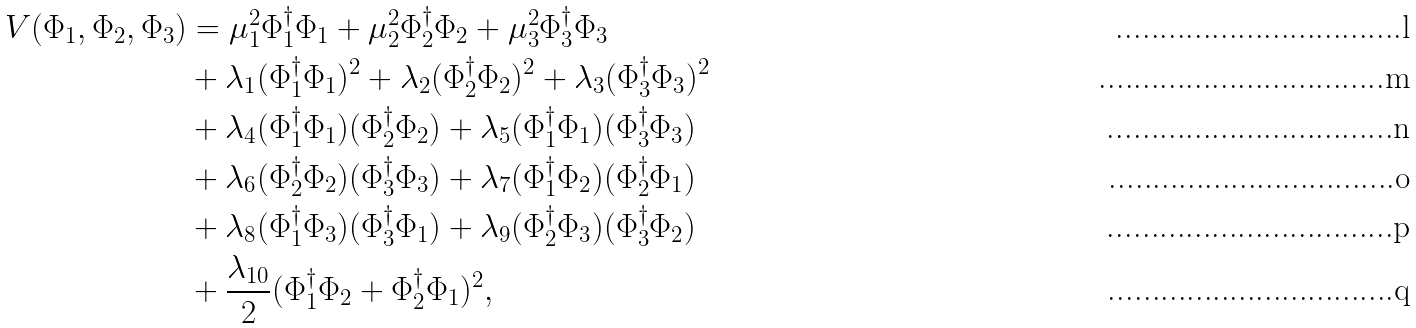<formula> <loc_0><loc_0><loc_500><loc_500>V ( \Phi _ { 1 } , \Phi _ { 2 } , \Phi _ { 3 } ) & = \mu _ { 1 } ^ { 2 } \Phi _ { 1 } ^ { \dag } \Phi _ { 1 } + \mu _ { 2 } ^ { 2 } \Phi _ { 2 } ^ { \dag } \Phi _ { 2 } + \mu _ { 3 } ^ { 2 } \Phi _ { 3 } ^ { \dag } \Phi _ { 3 } \\ & + \lambda _ { 1 } ( \Phi _ { 1 } ^ { \dag } \Phi _ { 1 } ) ^ { 2 } + \lambda _ { 2 } ( \Phi _ { 2 } ^ { \dag } \Phi _ { 2 } ) ^ { 2 } + \lambda _ { 3 } ( \Phi _ { 3 } ^ { \dag } \Phi _ { 3 } ) ^ { 2 } \\ & + \lambda _ { 4 } ( \Phi _ { 1 } ^ { \dag } \Phi _ { 1 } ) ( \Phi _ { 2 } ^ { \dag } \Phi _ { 2 } ) + \lambda _ { 5 } ( \Phi _ { 1 } ^ { \dag } \Phi _ { 1 } ) ( \Phi _ { 3 } ^ { \dag } \Phi _ { 3 } ) \\ & + \lambda _ { 6 } ( \Phi _ { 2 } ^ { \dag } \Phi _ { 2 } ) ( \Phi _ { 3 } ^ { \dag } \Phi _ { 3 } ) + \lambda _ { 7 } ( \Phi _ { 1 } ^ { \dag } \Phi _ { 2 } ) ( \Phi _ { 2 } ^ { \dag } \Phi _ { 1 } ) \\ & + \lambda _ { 8 } ( \Phi _ { 1 } ^ { \dag } \Phi _ { 3 } ) ( \Phi _ { 3 } ^ { \dag } \Phi _ { 1 } ) + \lambda _ { 9 } ( \Phi _ { 2 } ^ { \dag } \Phi _ { 3 } ) ( \Phi _ { 3 } ^ { \dag } \Phi _ { 2 } ) \\ & + \frac { \lambda _ { 1 0 } } { 2 } ( \Phi _ { 1 } ^ { \dag } \Phi _ { 2 } + \Phi _ { 2 } ^ { \dag } \Phi _ { 1 } ) ^ { 2 } ,</formula> 